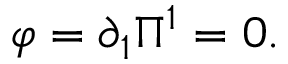<formula> <loc_0><loc_0><loc_500><loc_500>\varphi = \partial _ { 1 } \Pi ^ { 1 } = 0 .</formula> 